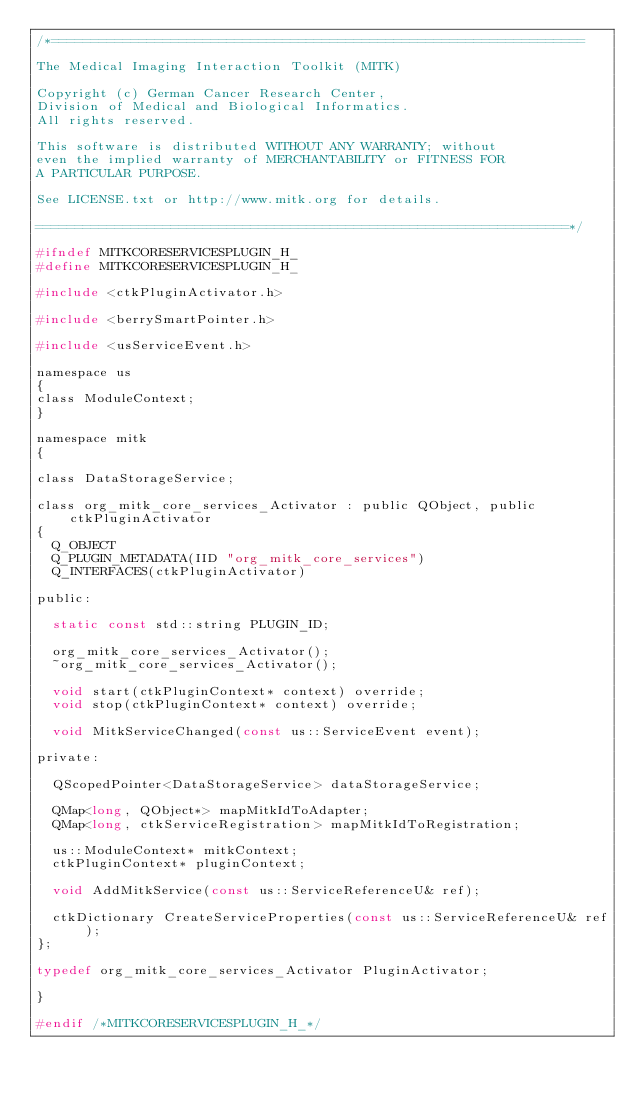<code> <loc_0><loc_0><loc_500><loc_500><_C_>/*===================================================================

The Medical Imaging Interaction Toolkit (MITK)

Copyright (c) German Cancer Research Center,
Division of Medical and Biological Informatics.
All rights reserved.

This software is distributed WITHOUT ANY WARRANTY; without
even the implied warranty of MERCHANTABILITY or FITNESS FOR
A PARTICULAR PURPOSE.

See LICENSE.txt or http://www.mitk.org for details.

===================================================================*/

#ifndef MITKCORESERVICESPLUGIN_H_
#define MITKCORESERVICESPLUGIN_H_

#include <ctkPluginActivator.h>

#include <berrySmartPointer.h>

#include <usServiceEvent.h>

namespace us
{
class ModuleContext;
}

namespace mitk
{

class DataStorageService;

class org_mitk_core_services_Activator : public QObject, public ctkPluginActivator
{
  Q_OBJECT
  Q_PLUGIN_METADATA(IID "org_mitk_core_services")
  Q_INTERFACES(ctkPluginActivator)

public:

  static const std::string PLUGIN_ID;

  org_mitk_core_services_Activator();
  ~org_mitk_core_services_Activator();

  void start(ctkPluginContext* context) override;
  void stop(ctkPluginContext* context) override;

  void MitkServiceChanged(const us::ServiceEvent event);

private:

  QScopedPointer<DataStorageService> dataStorageService;

  QMap<long, QObject*> mapMitkIdToAdapter;
  QMap<long, ctkServiceRegistration> mapMitkIdToRegistration;

  us::ModuleContext* mitkContext;
  ctkPluginContext* pluginContext;

  void AddMitkService(const us::ServiceReferenceU& ref);

  ctkDictionary CreateServiceProperties(const us::ServiceReferenceU& ref);
};

typedef org_mitk_core_services_Activator PluginActivator;

}

#endif /*MITKCORESERVICESPLUGIN_H_*/
</code> 